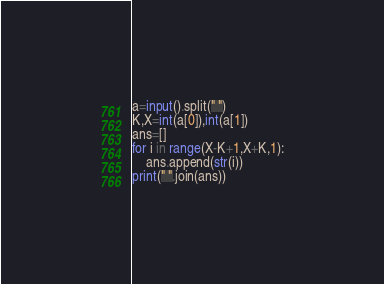Convert code to text. <code><loc_0><loc_0><loc_500><loc_500><_Python_>a=input().split(" ")
K,X=int(a[0]),int(a[1])
ans=[]
for i in range(X-K+1,X+K,1):
    ans.append(str(i))
print(" ".join(ans))</code> 